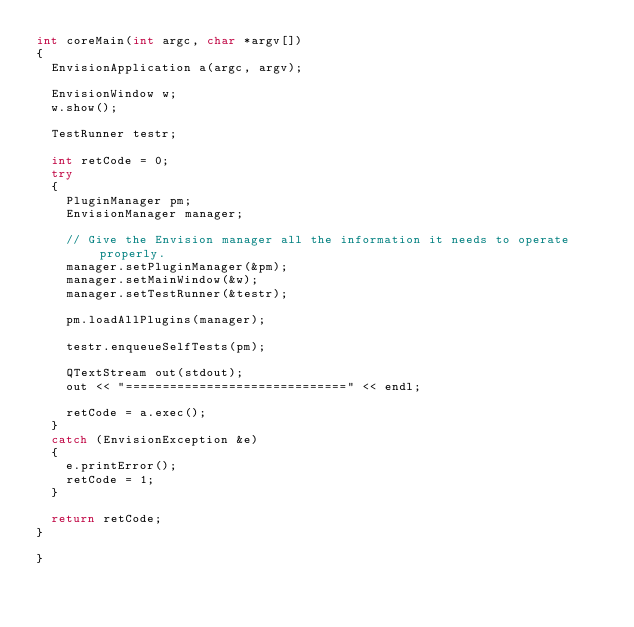Convert code to text. <code><loc_0><loc_0><loc_500><loc_500><_C++_>int coreMain(int argc, char *argv[])
{
	EnvisionApplication a(argc, argv);

	EnvisionWindow w;
	w.show();

	TestRunner testr;

	int retCode = 0;
	try
	{
		PluginManager pm;
		EnvisionManager manager;

		// Give the Envision manager all the information it needs to operate properly.
		manager.setPluginManager(&pm);
		manager.setMainWindow(&w);
		manager.setTestRunner(&testr);

		pm.loadAllPlugins(manager);

		testr.enqueueSelfTests(pm);

		QTextStream out(stdout);
		out << "==============================" << endl;

		retCode = a.exec();
	}
	catch (EnvisionException &e)
	{
		e.printError();
		retCode = 1;
	}

	return retCode;
}

}
</code> 